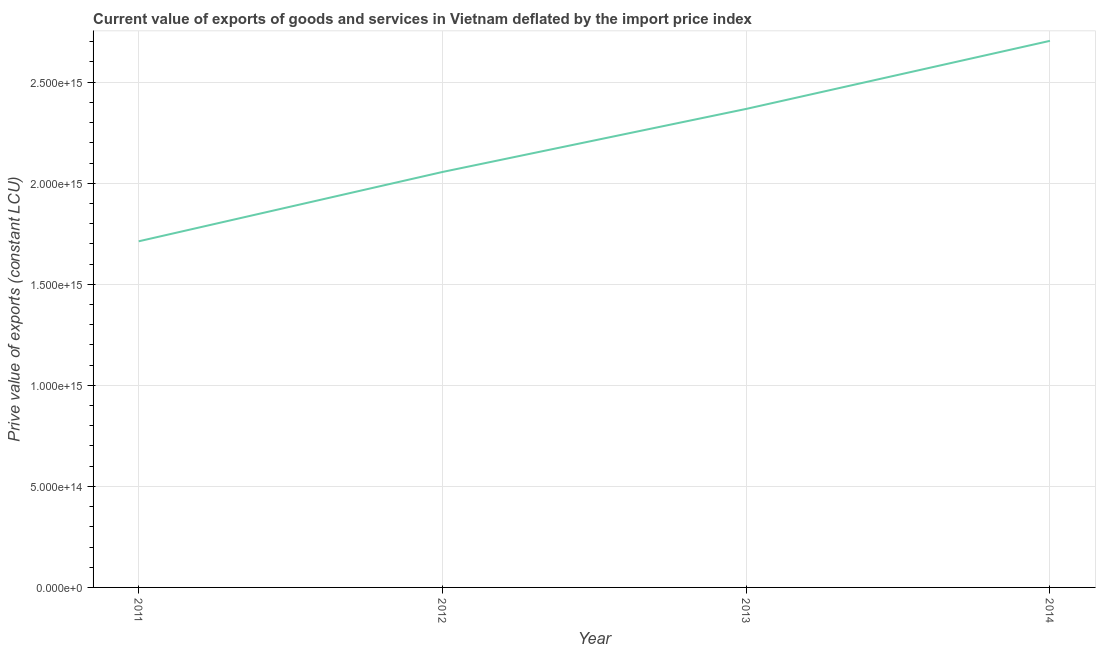What is the price value of exports in 2012?
Provide a succinct answer. 2.06e+15. Across all years, what is the maximum price value of exports?
Your answer should be very brief. 2.70e+15. Across all years, what is the minimum price value of exports?
Make the answer very short. 1.71e+15. What is the sum of the price value of exports?
Give a very brief answer. 8.84e+15. What is the difference between the price value of exports in 2012 and 2013?
Provide a short and direct response. -3.12e+14. What is the average price value of exports per year?
Offer a very short reply. 2.21e+15. What is the median price value of exports?
Your answer should be very brief. 2.21e+15. Do a majority of the years between 2013 and 2012 (inclusive) have price value of exports greater than 2200000000000000 LCU?
Your answer should be very brief. No. What is the ratio of the price value of exports in 2011 to that in 2013?
Provide a succinct answer. 0.72. What is the difference between the highest and the second highest price value of exports?
Your answer should be very brief. 3.37e+14. What is the difference between the highest and the lowest price value of exports?
Provide a short and direct response. 9.92e+14. Does the price value of exports monotonically increase over the years?
Provide a succinct answer. Yes. How many lines are there?
Offer a terse response. 1. What is the difference between two consecutive major ticks on the Y-axis?
Offer a terse response. 5.00e+14. Are the values on the major ticks of Y-axis written in scientific E-notation?
Ensure brevity in your answer.  Yes. What is the title of the graph?
Your answer should be very brief. Current value of exports of goods and services in Vietnam deflated by the import price index. What is the label or title of the Y-axis?
Your answer should be very brief. Prive value of exports (constant LCU). What is the Prive value of exports (constant LCU) of 2011?
Your answer should be very brief. 1.71e+15. What is the Prive value of exports (constant LCU) of 2012?
Offer a terse response. 2.06e+15. What is the Prive value of exports (constant LCU) of 2013?
Offer a very short reply. 2.37e+15. What is the Prive value of exports (constant LCU) in 2014?
Provide a succinct answer. 2.70e+15. What is the difference between the Prive value of exports (constant LCU) in 2011 and 2012?
Your answer should be compact. -3.43e+14. What is the difference between the Prive value of exports (constant LCU) in 2011 and 2013?
Your answer should be very brief. -6.55e+14. What is the difference between the Prive value of exports (constant LCU) in 2011 and 2014?
Ensure brevity in your answer.  -9.92e+14. What is the difference between the Prive value of exports (constant LCU) in 2012 and 2013?
Give a very brief answer. -3.12e+14. What is the difference between the Prive value of exports (constant LCU) in 2012 and 2014?
Provide a short and direct response. -6.49e+14. What is the difference between the Prive value of exports (constant LCU) in 2013 and 2014?
Provide a short and direct response. -3.37e+14. What is the ratio of the Prive value of exports (constant LCU) in 2011 to that in 2012?
Your answer should be compact. 0.83. What is the ratio of the Prive value of exports (constant LCU) in 2011 to that in 2013?
Provide a short and direct response. 0.72. What is the ratio of the Prive value of exports (constant LCU) in 2011 to that in 2014?
Provide a short and direct response. 0.63. What is the ratio of the Prive value of exports (constant LCU) in 2012 to that in 2013?
Provide a succinct answer. 0.87. What is the ratio of the Prive value of exports (constant LCU) in 2012 to that in 2014?
Provide a short and direct response. 0.76. 